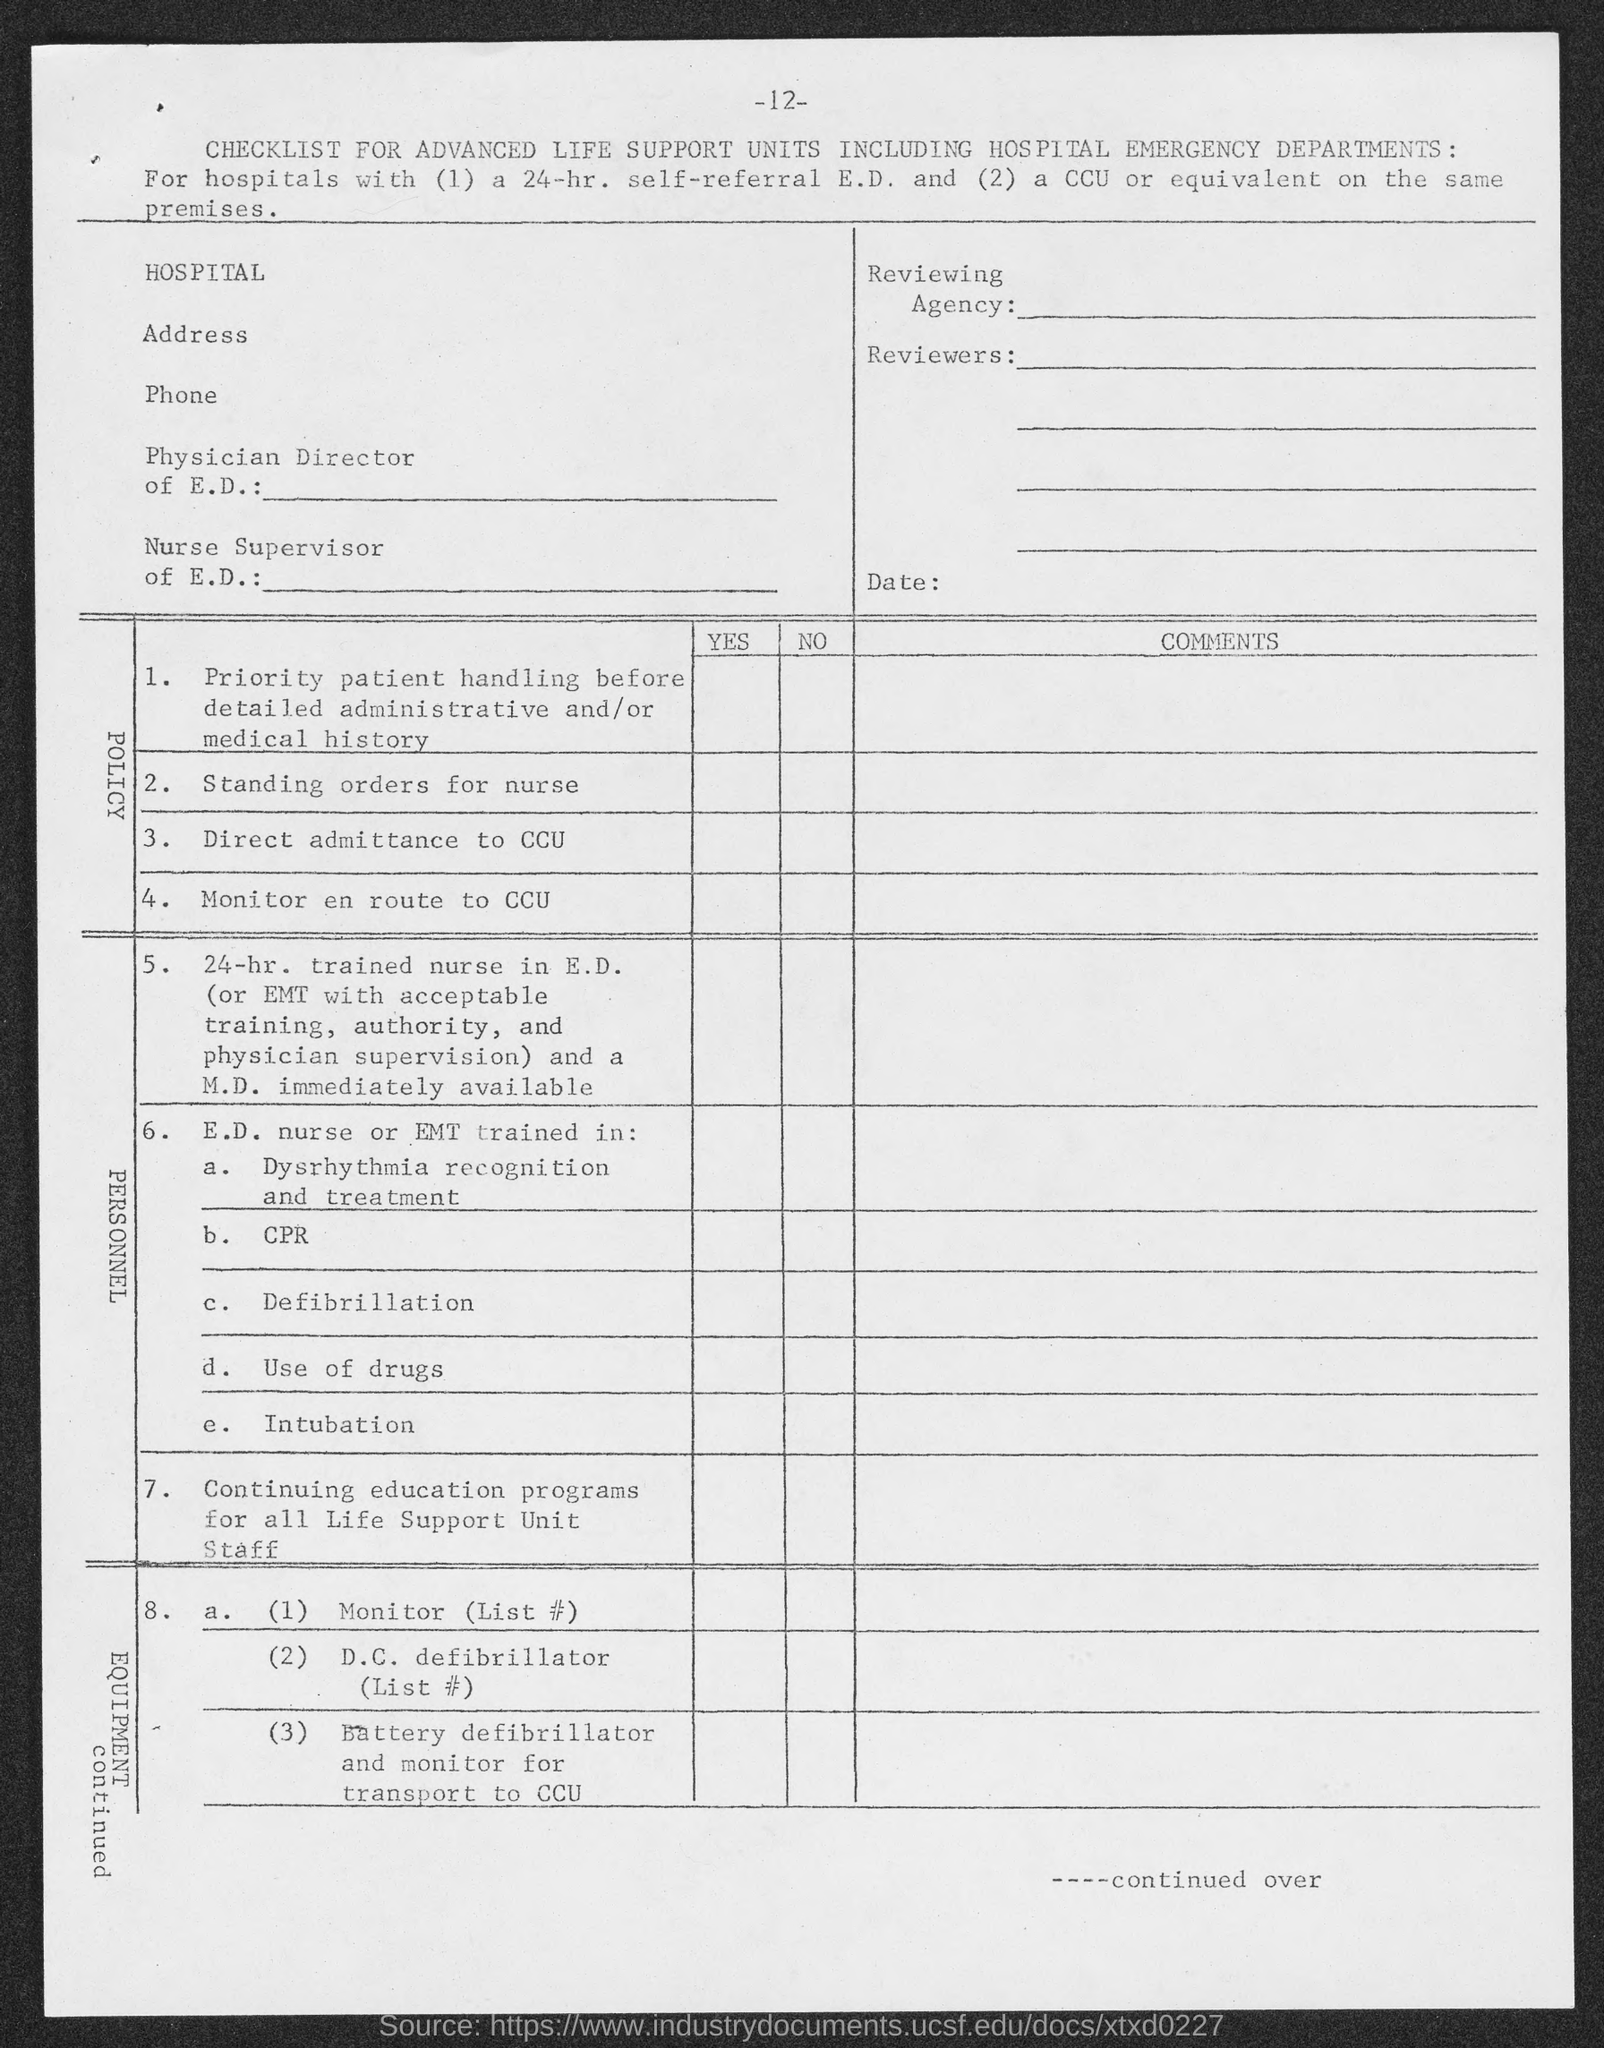What is the page number at top of the page?
Give a very brief answer. 12. 